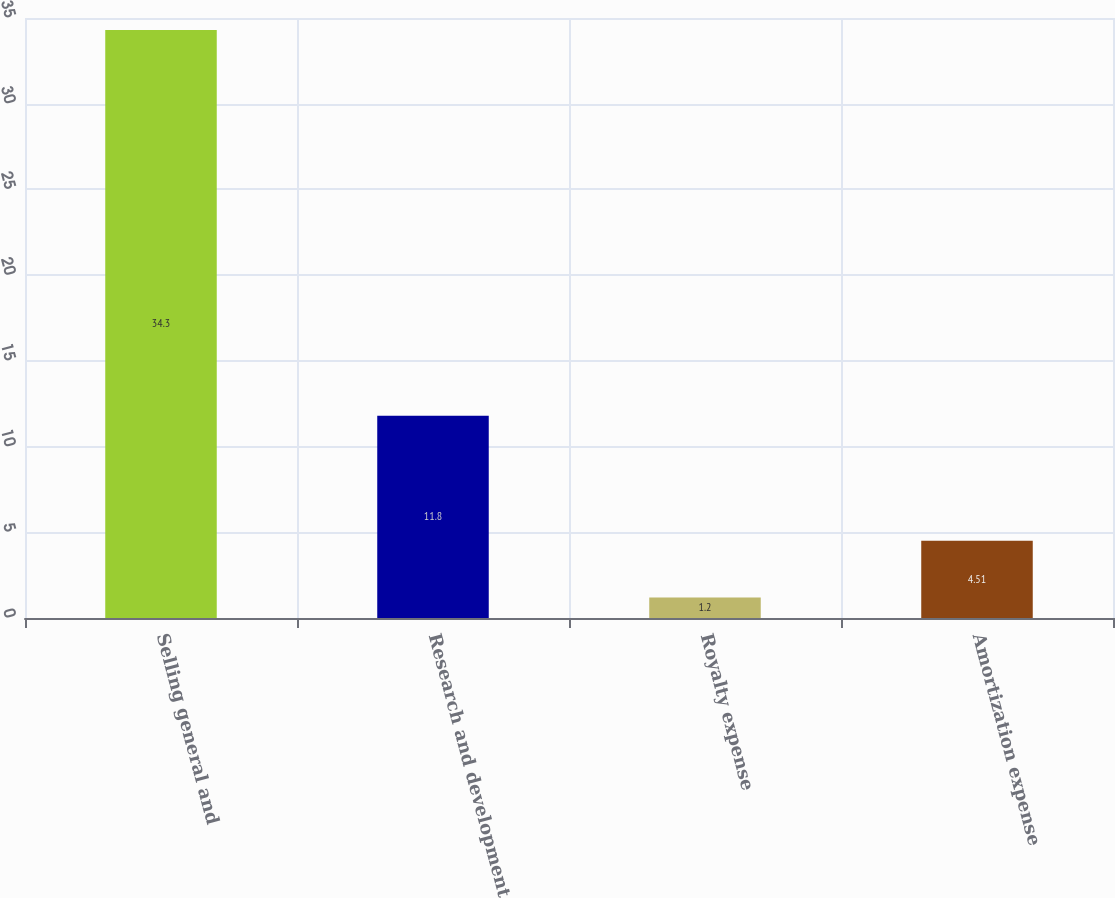<chart> <loc_0><loc_0><loc_500><loc_500><bar_chart><fcel>Selling general and<fcel>Research and development<fcel>Royalty expense<fcel>Amortization expense<nl><fcel>34.3<fcel>11.8<fcel>1.2<fcel>4.51<nl></chart> 